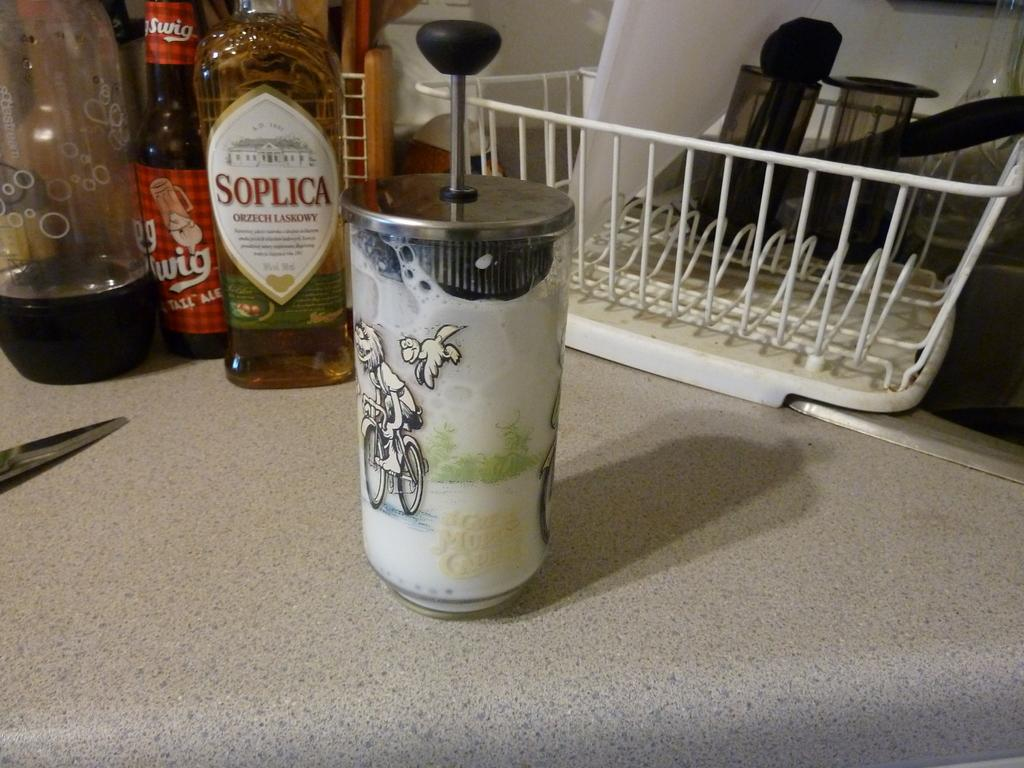Provide a one-sentence caption for the provided image. A bottle of Soplica next to red bottle in a kitchen. 